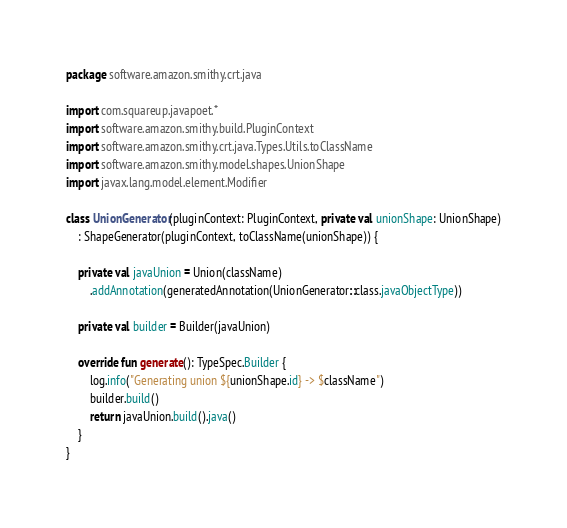Convert code to text. <code><loc_0><loc_0><loc_500><loc_500><_Kotlin_>package software.amazon.smithy.crt.java

import com.squareup.javapoet.*
import software.amazon.smithy.build.PluginContext
import software.amazon.smithy.crt.java.Types.Utils.toClassName
import software.amazon.smithy.model.shapes.UnionShape
import javax.lang.model.element.Modifier

class UnionGenerator(pluginContext: PluginContext, private val unionShape: UnionShape)
    : ShapeGenerator(pluginContext, toClassName(unionShape)) {

    private val javaUnion = Union(className)
        .addAnnotation(generatedAnnotation(UnionGenerator::class.javaObjectType))

    private val builder = Builder(javaUnion)

    override fun generate(): TypeSpec.Builder {
        log.info("Generating union ${unionShape.id} -> $className")
        builder.build()
        return javaUnion.build().java()
    }
}</code> 